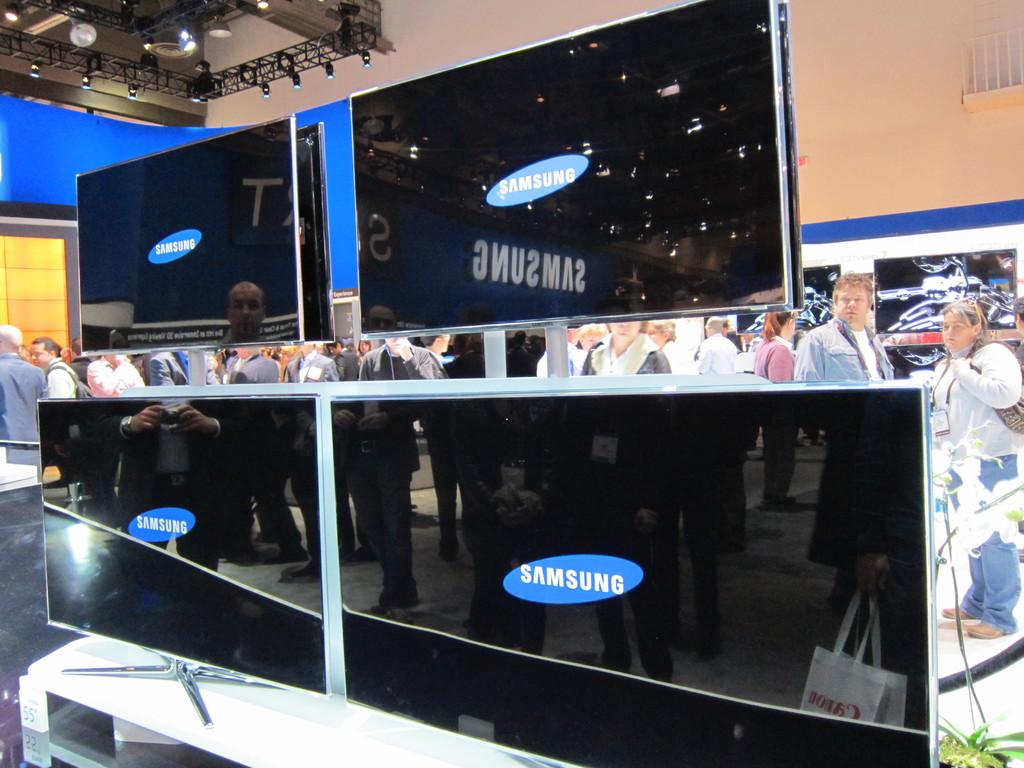What brand of tv's are these?
Provide a short and direct response. Samsung. 